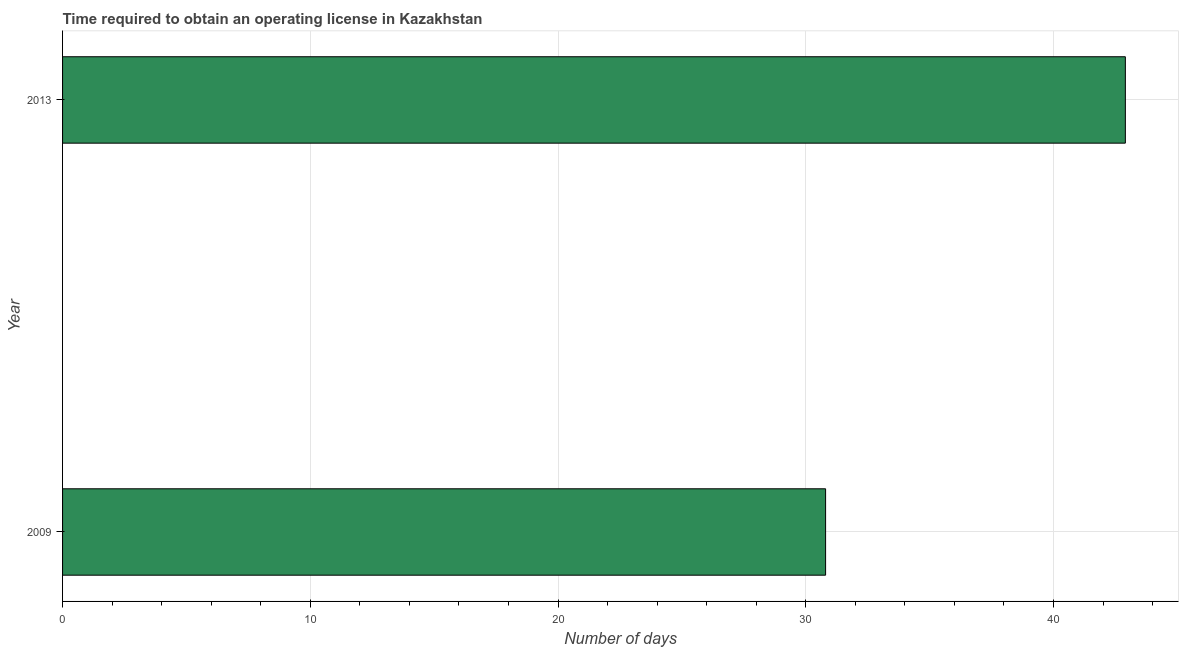Does the graph contain any zero values?
Offer a very short reply. No. What is the title of the graph?
Offer a terse response. Time required to obtain an operating license in Kazakhstan. What is the label or title of the X-axis?
Provide a short and direct response. Number of days. What is the number of days to obtain operating license in 2013?
Offer a terse response. 42.9. Across all years, what is the maximum number of days to obtain operating license?
Your answer should be very brief. 42.9. Across all years, what is the minimum number of days to obtain operating license?
Ensure brevity in your answer.  30.8. In which year was the number of days to obtain operating license minimum?
Ensure brevity in your answer.  2009. What is the sum of the number of days to obtain operating license?
Your answer should be very brief. 73.7. What is the difference between the number of days to obtain operating license in 2009 and 2013?
Ensure brevity in your answer.  -12.1. What is the average number of days to obtain operating license per year?
Provide a short and direct response. 36.85. What is the median number of days to obtain operating license?
Offer a very short reply. 36.85. Do a majority of the years between 2009 and 2013 (inclusive) have number of days to obtain operating license greater than 18 days?
Offer a very short reply. Yes. What is the ratio of the number of days to obtain operating license in 2009 to that in 2013?
Your response must be concise. 0.72. In how many years, is the number of days to obtain operating license greater than the average number of days to obtain operating license taken over all years?
Your response must be concise. 1. What is the difference between two consecutive major ticks on the X-axis?
Offer a very short reply. 10. What is the Number of days of 2009?
Offer a very short reply. 30.8. What is the Number of days of 2013?
Keep it short and to the point. 42.9. What is the difference between the Number of days in 2009 and 2013?
Provide a succinct answer. -12.1. What is the ratio of the Number of days in 2009 to that in 2013?
Your answer should be compact. 0.72. 